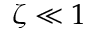Convert formula to latex. <formula><loc_0><loc_0><loc_500><loc_500>\zeta \ll 1</formula> 